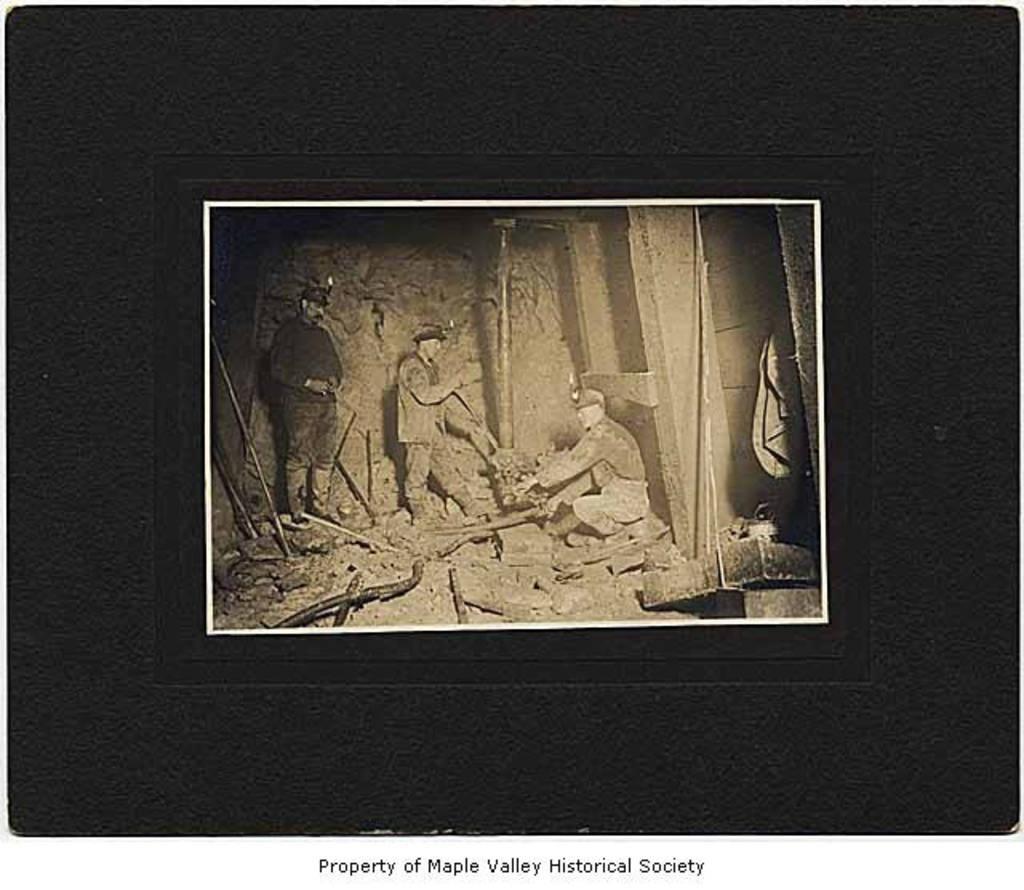Could you give a brief overview of what you see in this image? In this image we can see a photograph, in the photograph we can see a few people among them one person is sitting and there are some poles, stones and other objects. 